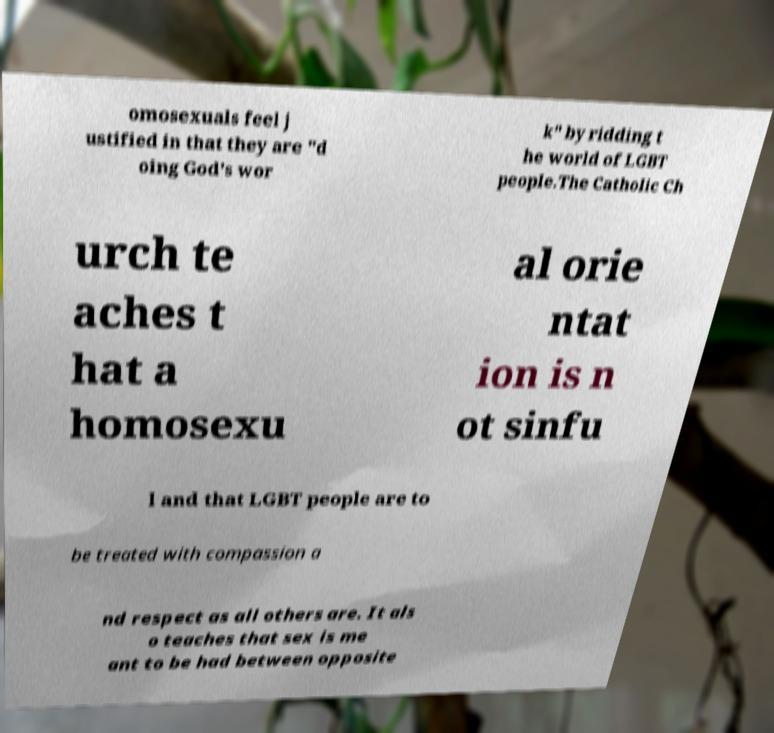There's text embedded in this image that I need extracted. Can you transcribe it verbatim? omosexuals feel j ustified in that they are "d oing God's wor k" by ridding t he world of LGBT people.The Catholic Ch urch te aches t hat a homosexu al orie ntat ion is n ot sinfu l and that LGBT people are to be treated with compassion a nd respect as all others are. It als o teaches that sex is me ant to be had between opposite 